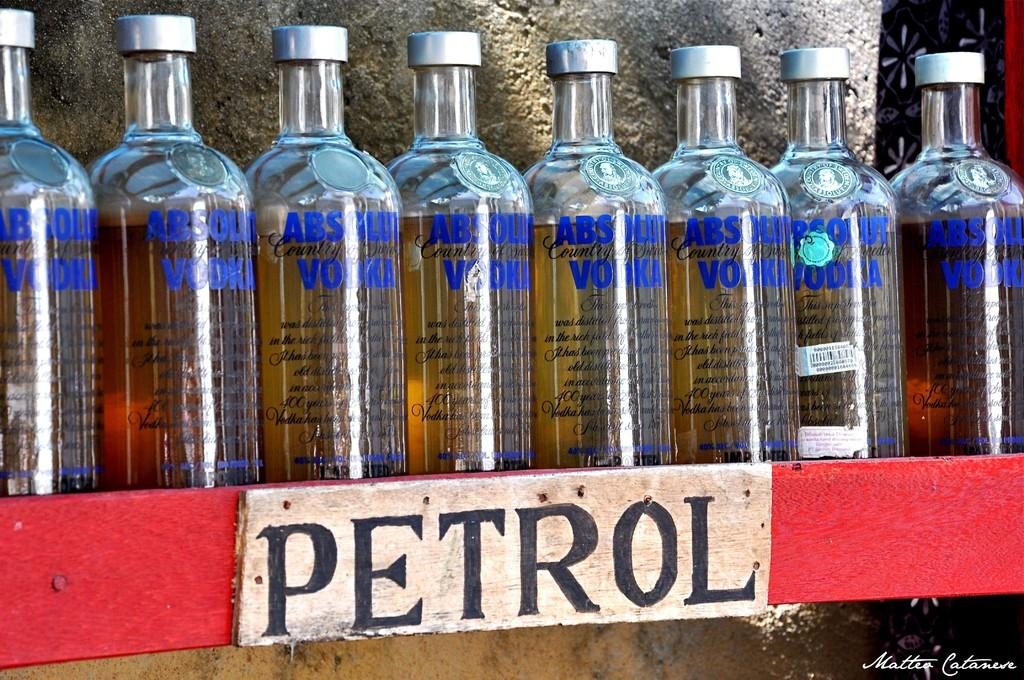What type of containers are visible in the image? There are glass bottles with liquid in the image. What is the liquid inside the bottles? The liquid in the bottles is likely to be petrol, as indicated by the board with the "petrol" writing. What word is written on the board in the image? There is a board with the word "petrol" in the image. What can be seen in the background of the image? There is a wall visible in the background of the image. Can you see a snake slithering near the bottles in the image? No, there is no snake present in the image. Is there a bomb visible in the image? No, there is no bomb present in the image. 